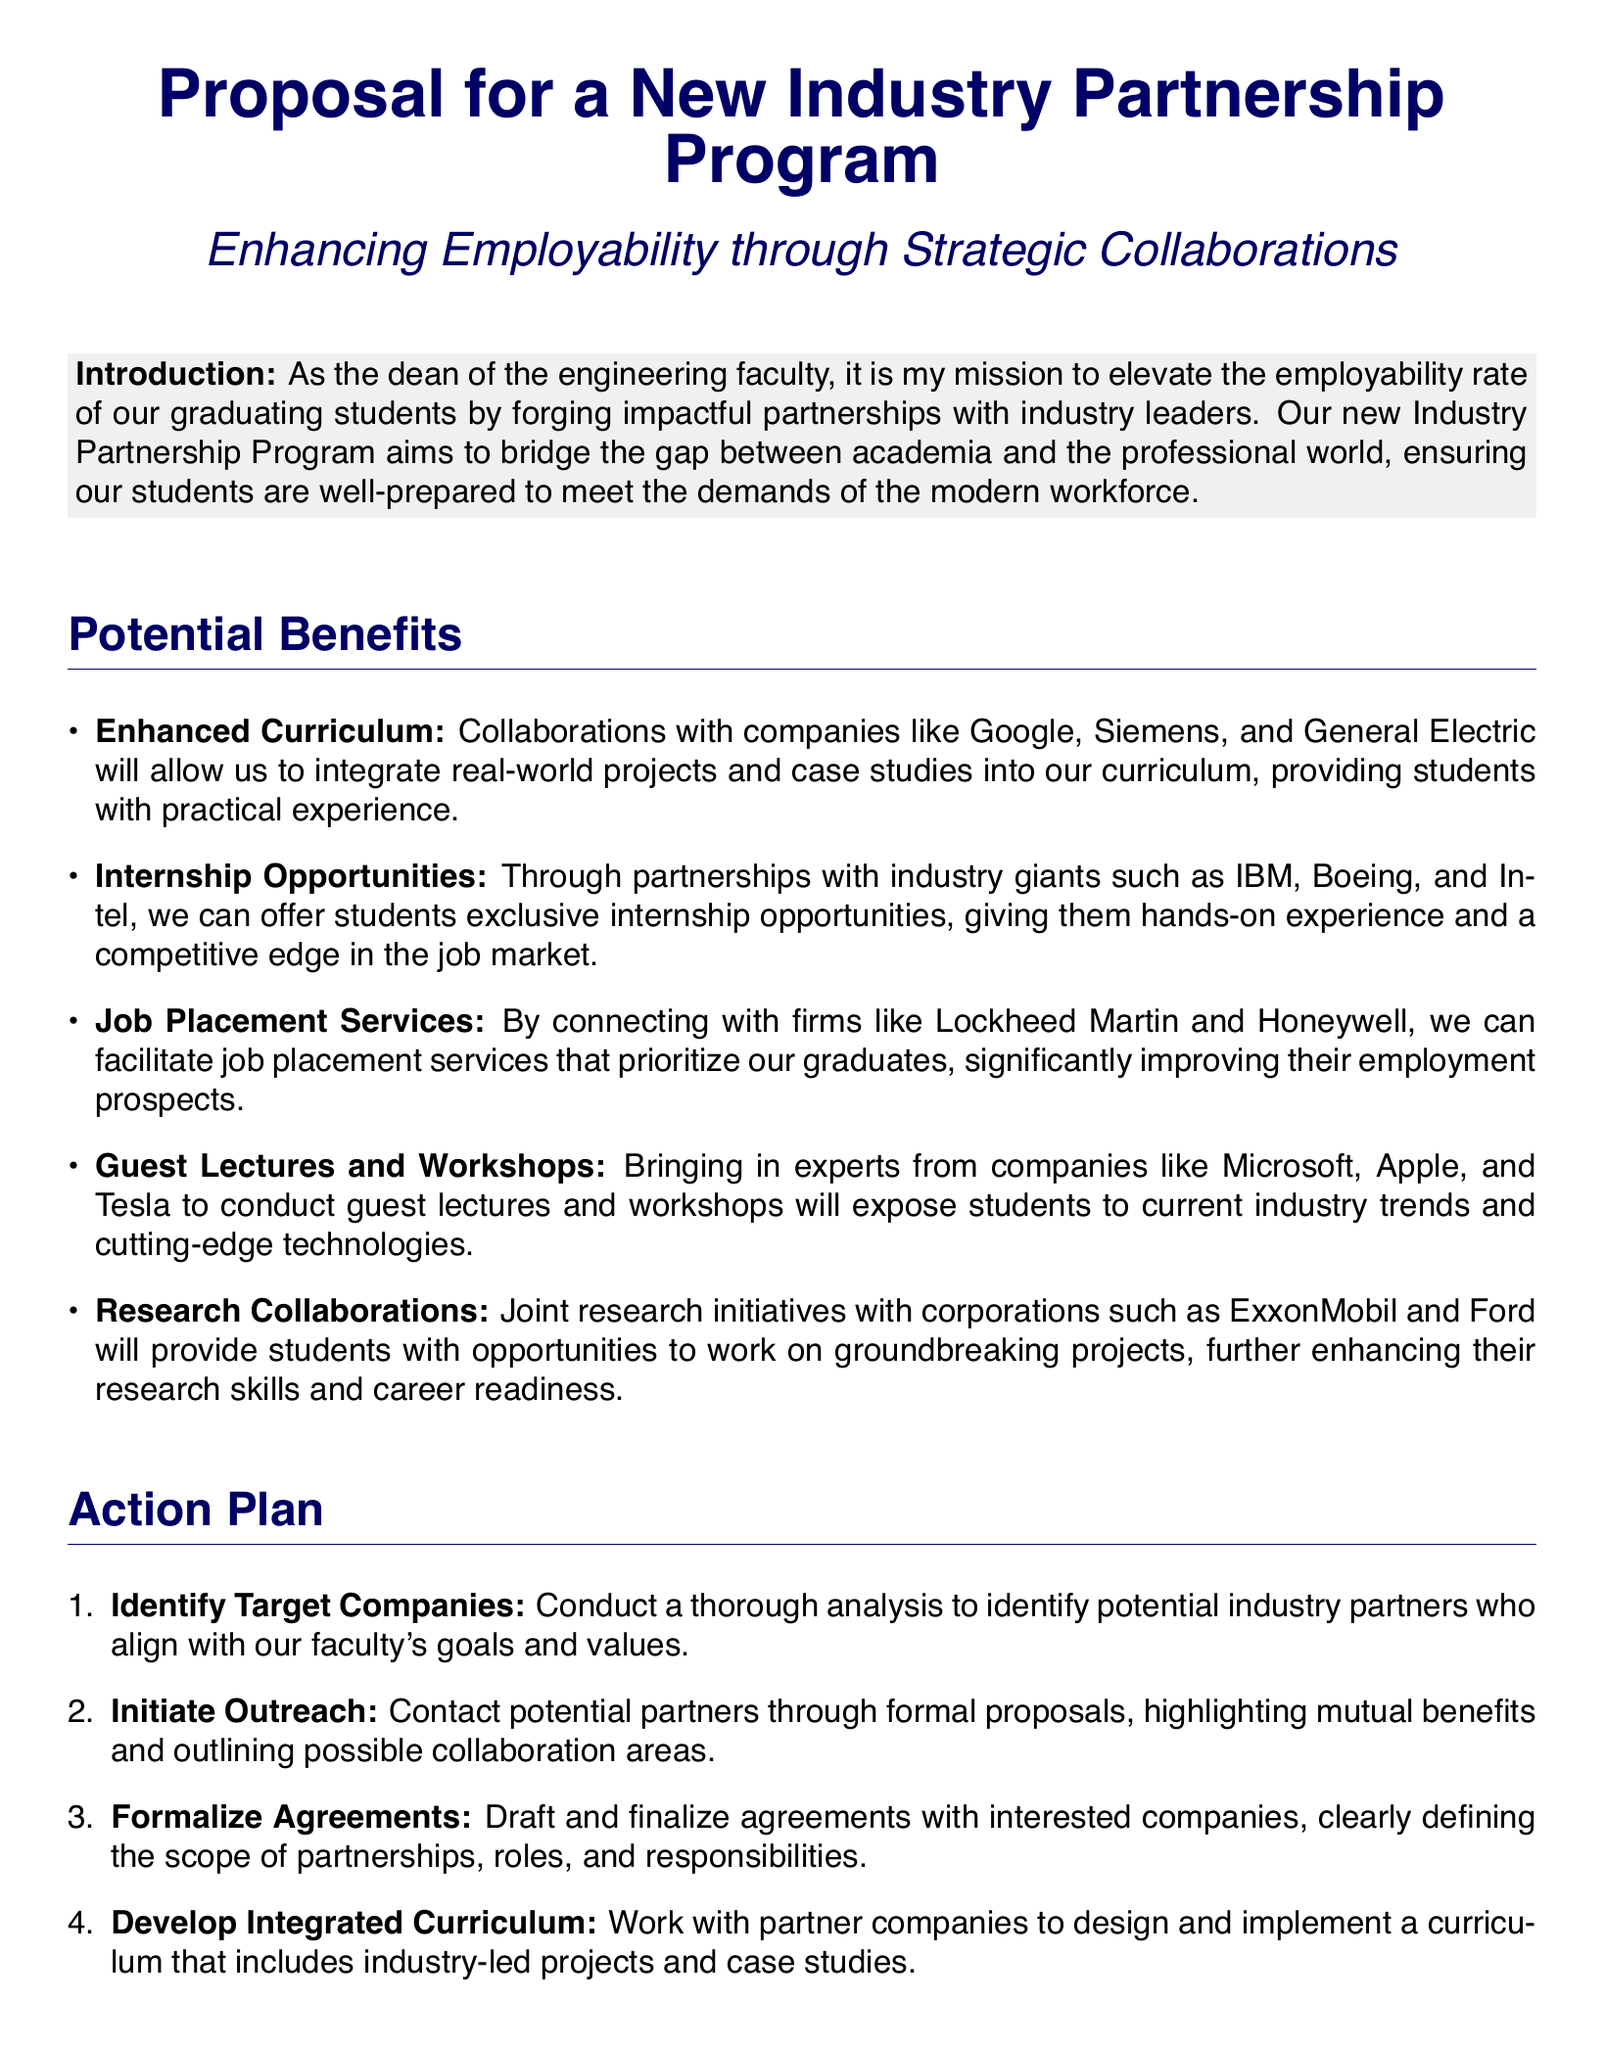What is the title of the proposal? The title of the proposal is prominently presented at the top of the document, which is "Proposal for a New Industry Partnership Program."
Answer: Proposal for a New Industry Partnership Program What is the main aim of the Industry Partnership Program? The main aim is described in the introduction, which focuses on enhancing the employability of graduating students through partnerships with industry leaders.
Answer: Enhancing employability Which companies are mentioned for enhanced curriculum collaboration? The document specifically mentions Google, Siemens, and General Electric as companies for curriculum collaboration.
Answer: Google, Siemens, General Electric What type of opportunities will the program provide? The program is expected to provide exclusive internship opportunities to students, as noted in the benefits section.
Answer: Internship opportunities What is the first step in the action plan? The document states that identifying target companies is the first step in the action plan.
Answer: Identify Target Companies Who will be conducting guest lectures and workshops? The document mentions experts from companies like Microsoft, Apple, and Tesla will conduct guest lectures and workshops.
Answer: Microsoft, Apple, Tesla What is the final step outlined in the action plan? The last step in the action plan involves monitoring and evaluating the effectiveness of the partnership program.
Answer: Monitor and Evaluate What contact information is provided at the end of the document? The document provides the dean's email and phone number as contact information: engineeringdean@university.edu and +1-234-567-8900.
Answer: engineeringdean@university.edu, +1-234-567-8900 What will the partnerships facilitate? The partnerships will facilitate job placement services that prioritize the graduates of the program.
Answer: Job Placement Services 